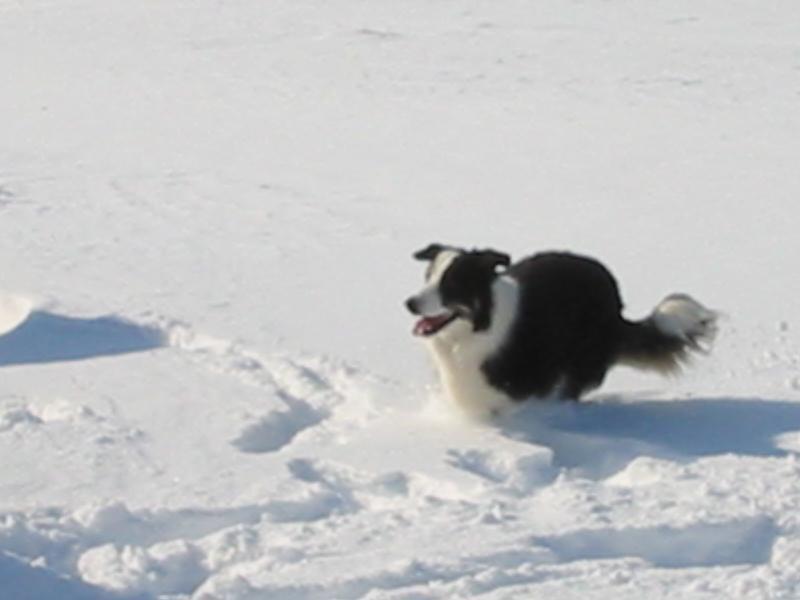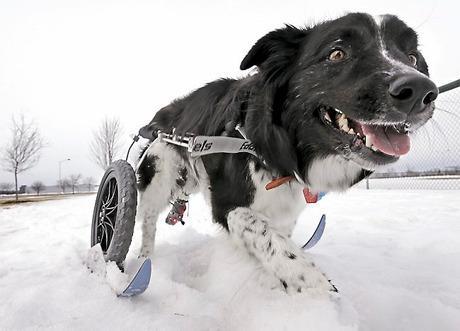The first image is the image on the left, the second image is the image on the right. Given the left and right images, does the statement "There are no more than two dogs." hold true? Answer yes or no. Yes. 